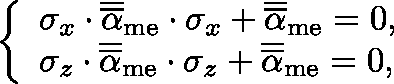<formula> <loc_0><loc_0><loc_500><loc_500>\left \{ \begin{array} { l l } { \sigma _ { x } \cdot \overline { { \overline { \alpha } } } _ { m e } \cdot \sigma _ { x } + \overline { { \overline { \alpha } } } _ { m e } = 0 , } \\ { \sigma _ { z } \cdot \overline { { \overline { \alpha } } } _ { m e } \cdot \sigma _ { z } + \overline { { \overline { \alpha } } } _ { m e } = 0 , } \end{array}</formula> 